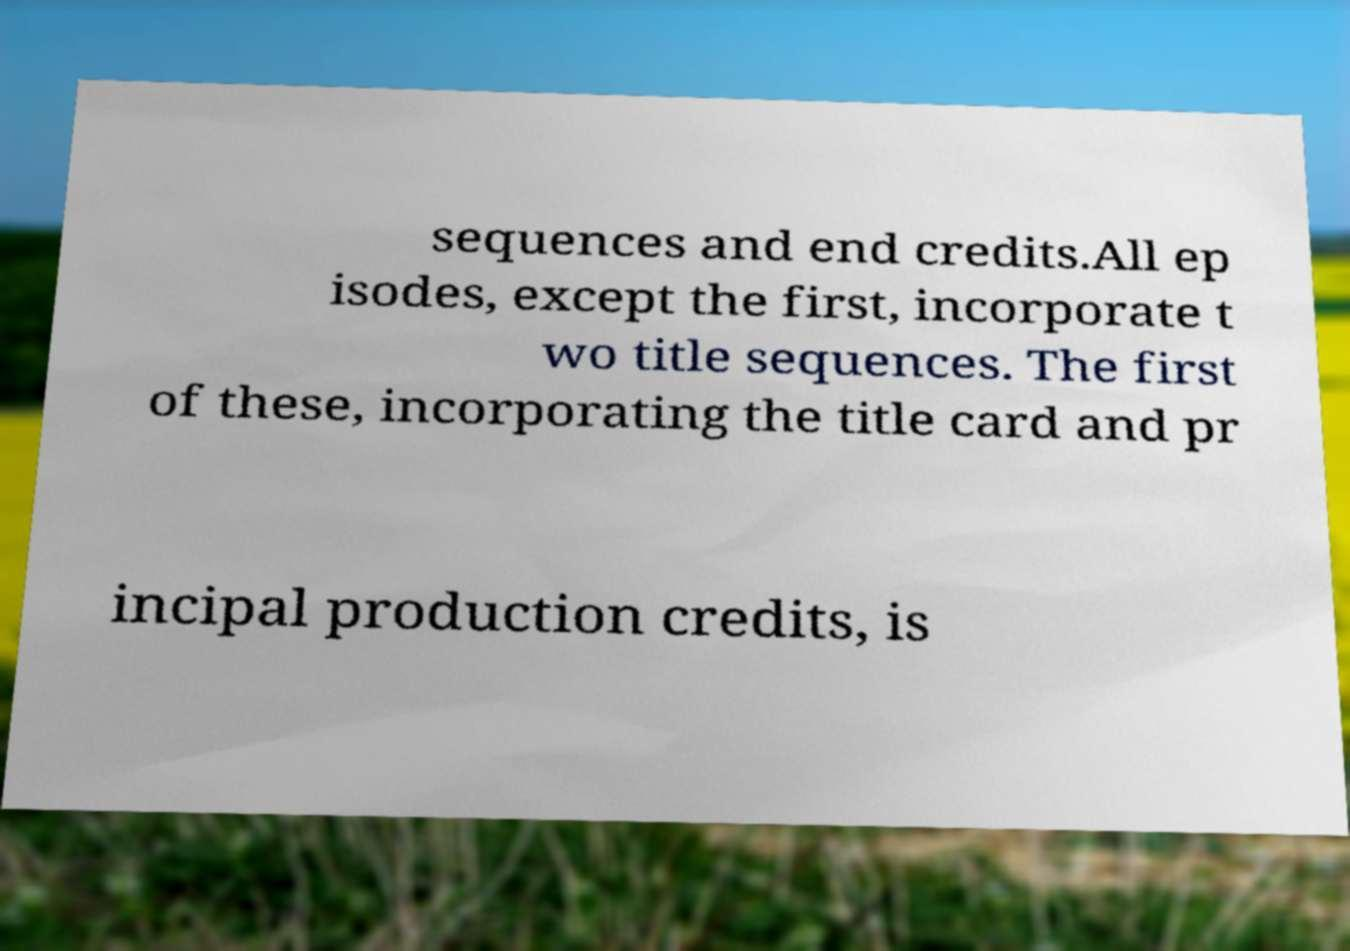For documentation purposes, I need the text within this image transcribed. Could you provide that? sequences and end credits.All ep isodes, except the first, incorporate t wo title sequences. The first of these, incorporating the title card and pr incipal production credits, is 